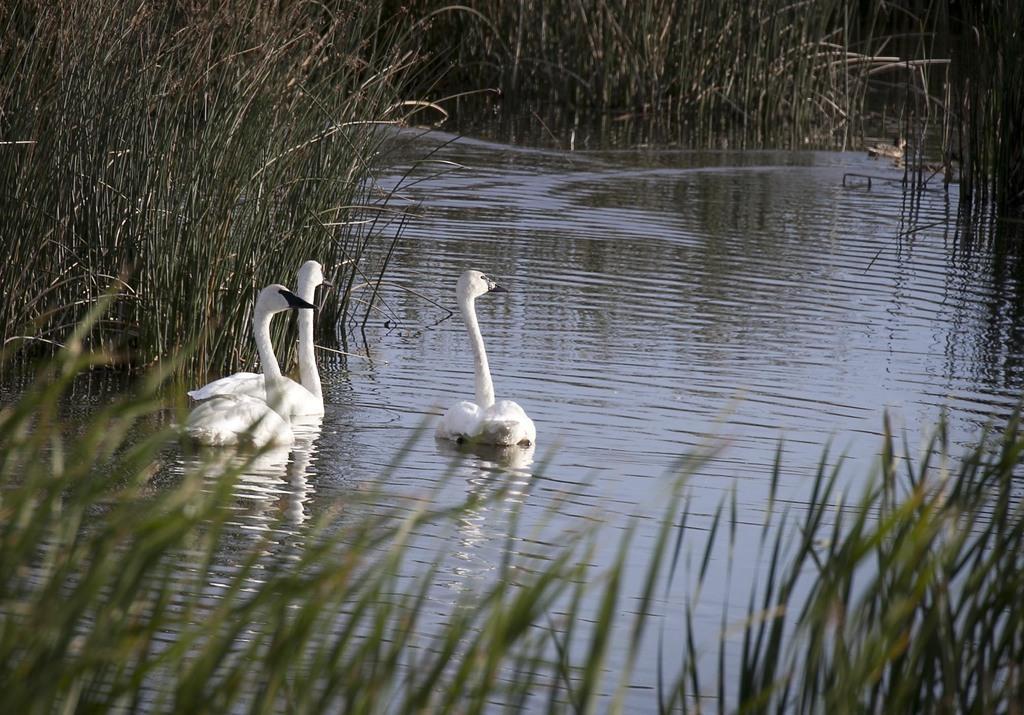Can you describe this image briefly? This image consists of three swans in the water. They are in white color. At the bottom, there is grass. In the middle, there is water. 